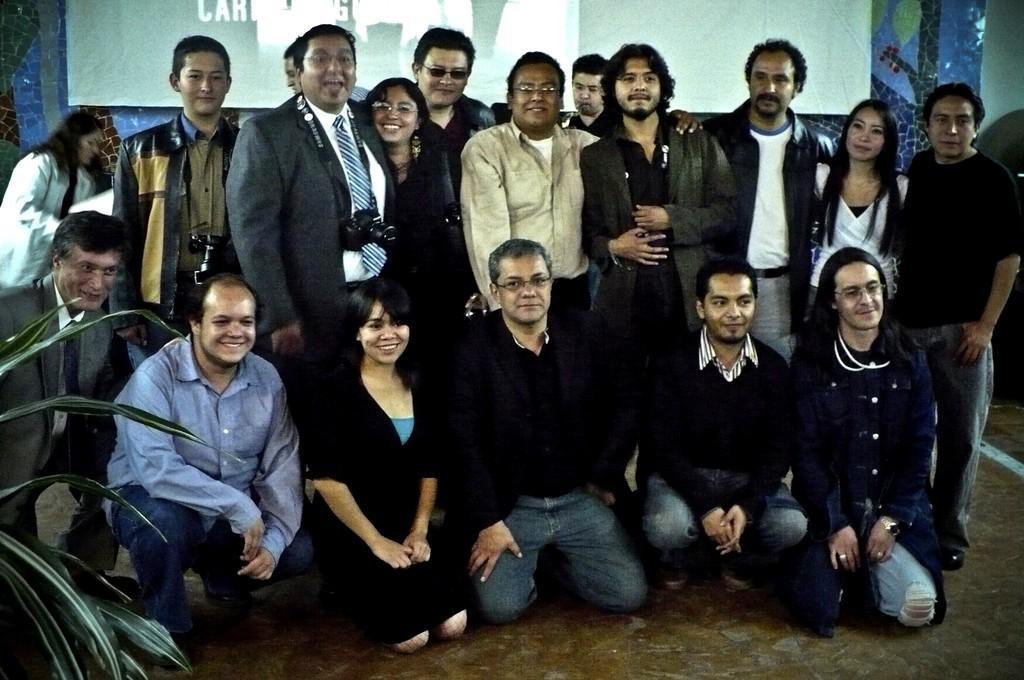In one or two sentences, can you explain what this image depicts? This image is taken indoors. At the bottom of the image there is a floor. On the left side of the image there is a plant. In the background there is a screen on the wall. In the middle of the image many people are standing and a few are sitting on the floor and they are with smiling faces. 